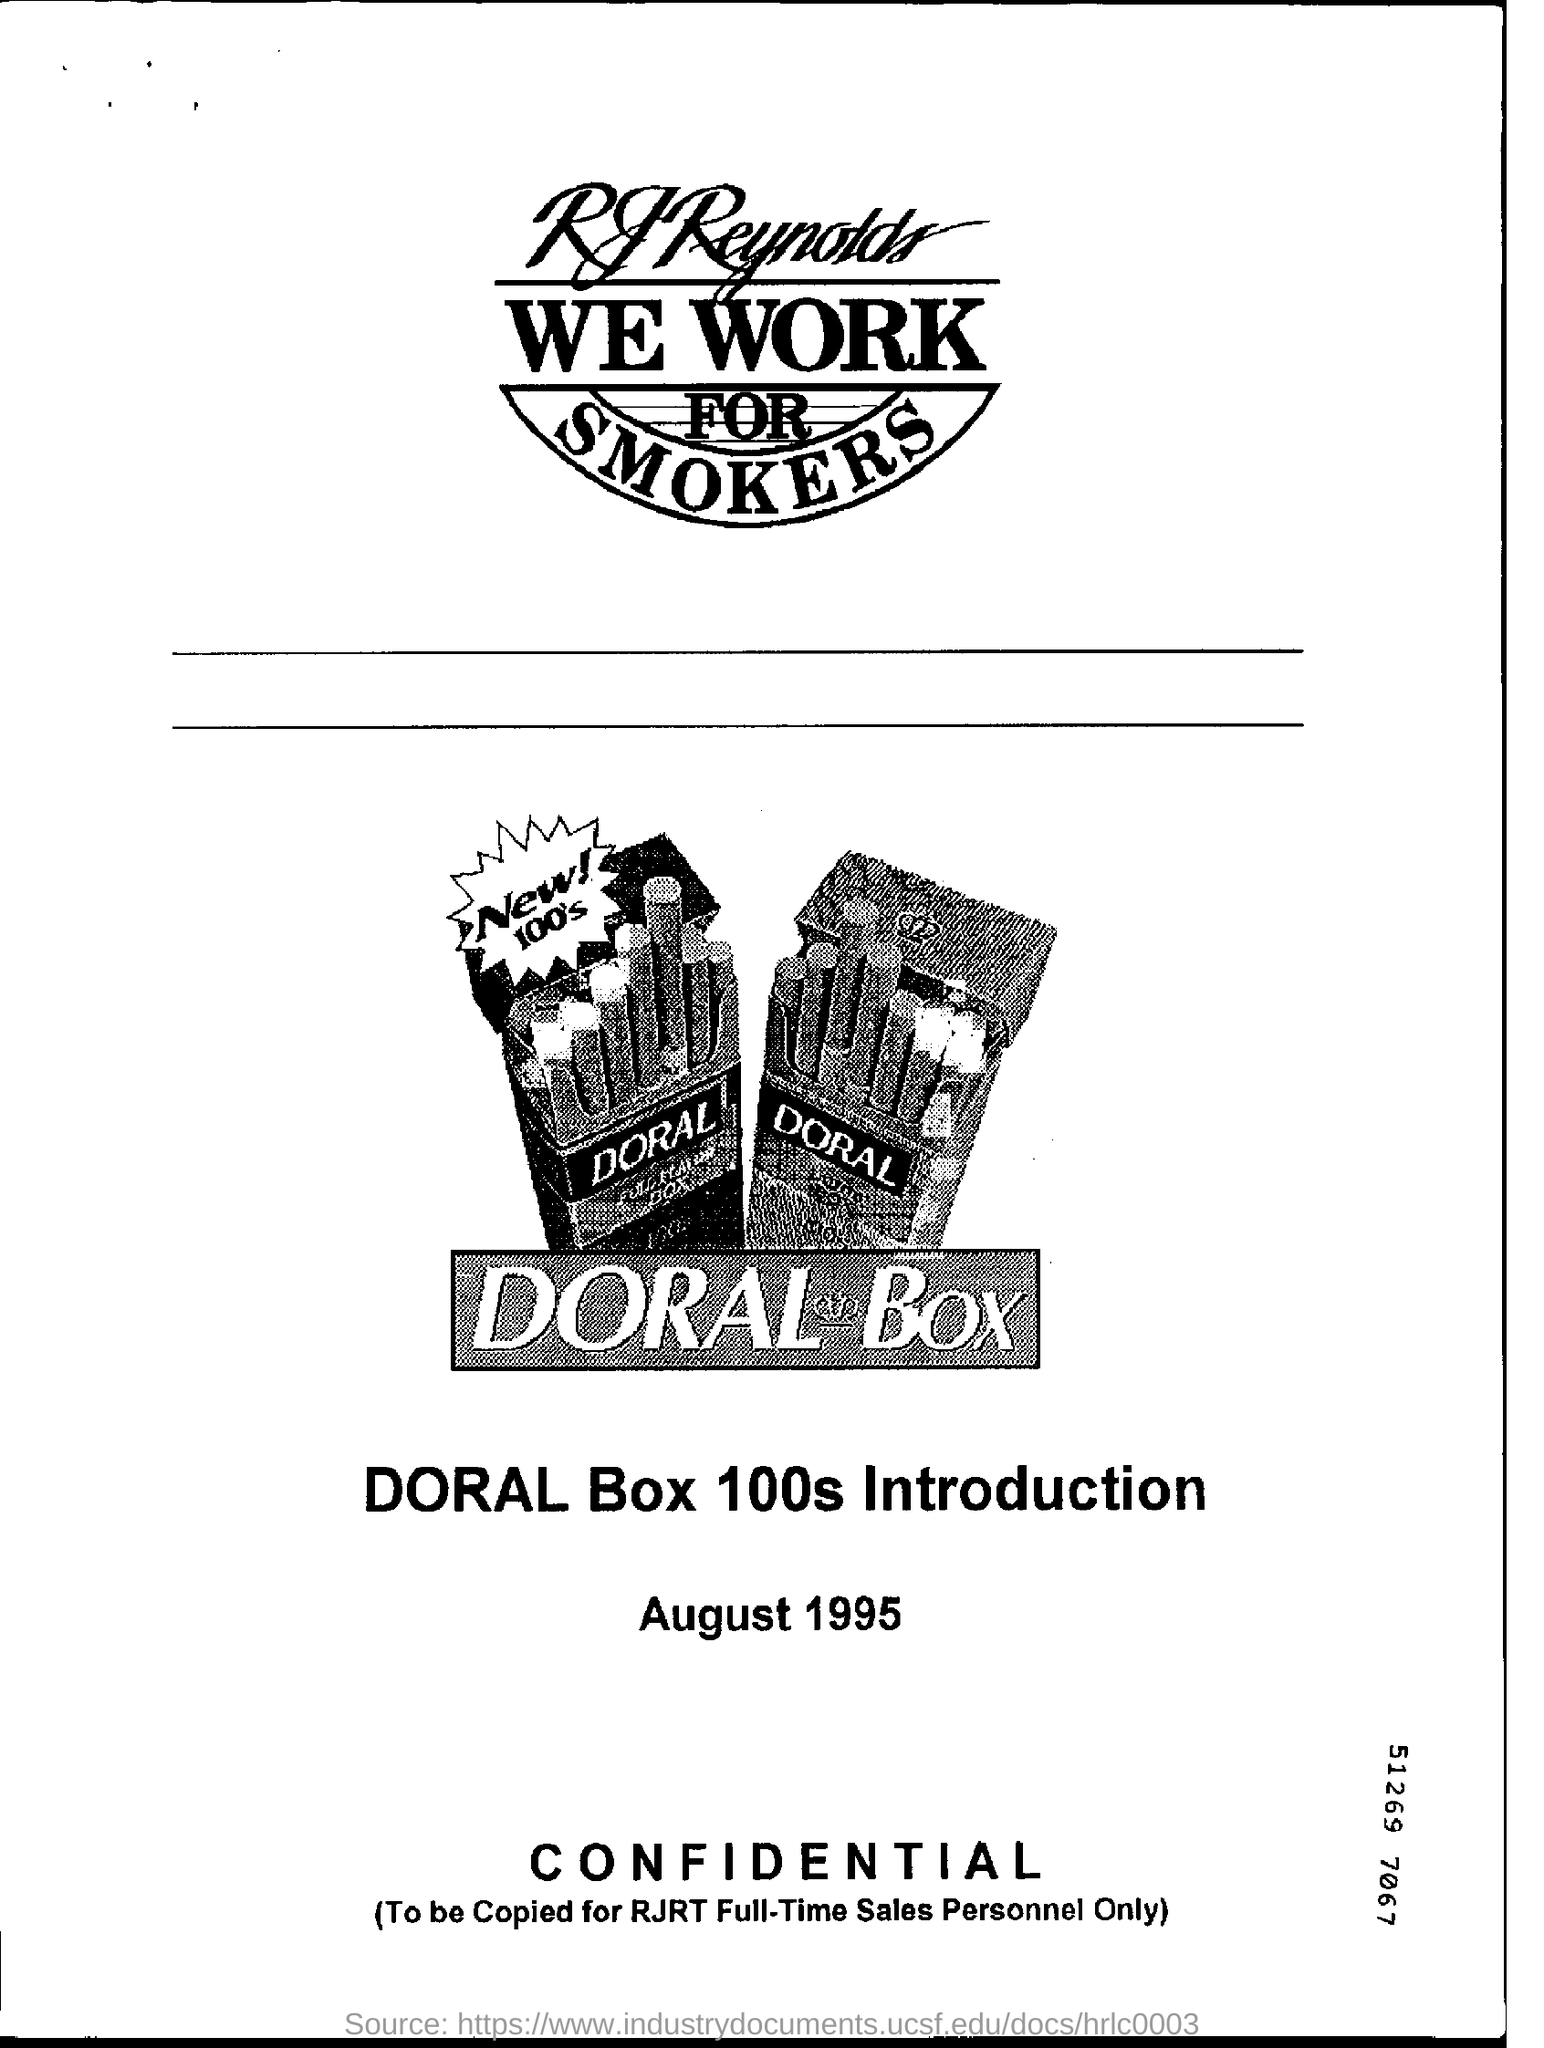Give some essential details in this illustration. Doral Box 100s, a new brand, will be introduced. 